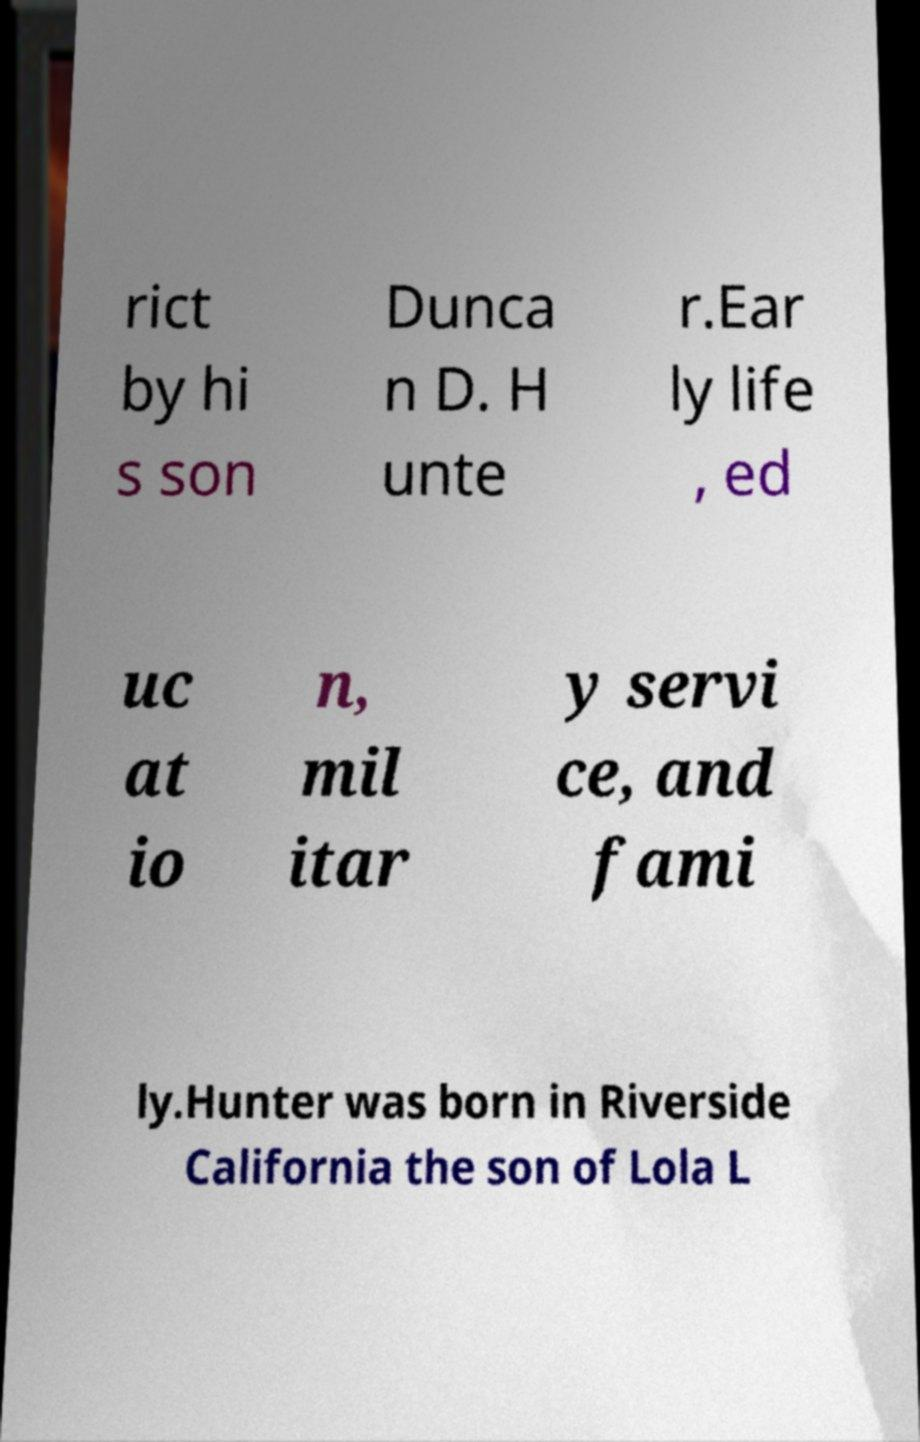Can you read and provide the text displayed in the image?This photo seems to have some interesting text. Can you extract and type it out for me? rict by hi s son Dunca n D. H unte r.Ear ly life , ed uc at io n, mil itar y servi ce, and fami ly.Hunter was born in Riverside California the son of Lola L 